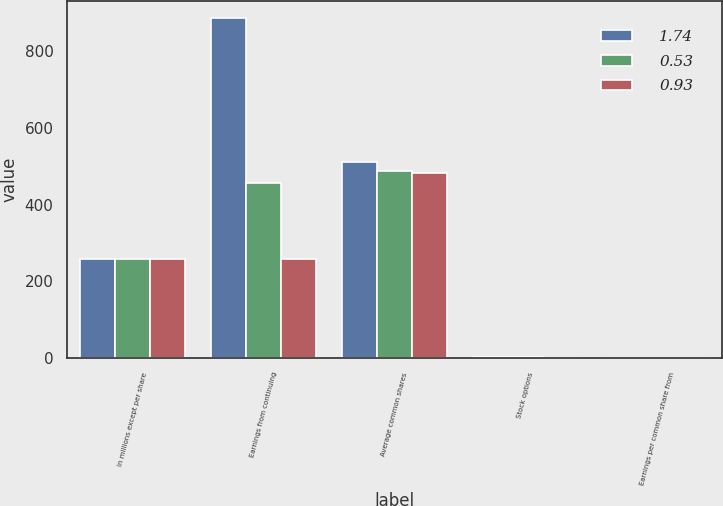Convert chart. <chart><loc_0><loc_0><loc_500><loc_500><stacked_bar_chart><ecel><fcel>In millions except per share<fcel>Earnings from continuing<fcel>Average common shares<fcel>Stock options<fcel>Earnings per common share from<nl><fcel>1.74<fcel>258<fcel>886<fcel>509.7<fcel>2.9<fcel>1.74<nl><fcel>0.53<fcel>258<fcel>456<fcel>488.4<fcel>2.6<fcel>0.93<nl><fcel>0.93<fcel>258<fcel>258<fcel>481.1<fcel>1.5<fcel>0.53<nl></chart> 